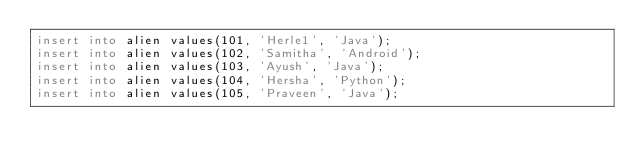<code> <loc_0><loc_0><loc_500><loc_500><_SQL_>insert into alien values(101, 'Herle1', 'Java');
insert into alien values(102, 'Samitha', 'Android');
insert into alien values(103, 'Ayush', 'Java');
insert into alien values(104, 'Hersha', 'Python');
insert into alien values(105, 'Praveen', 'Java');</code> 